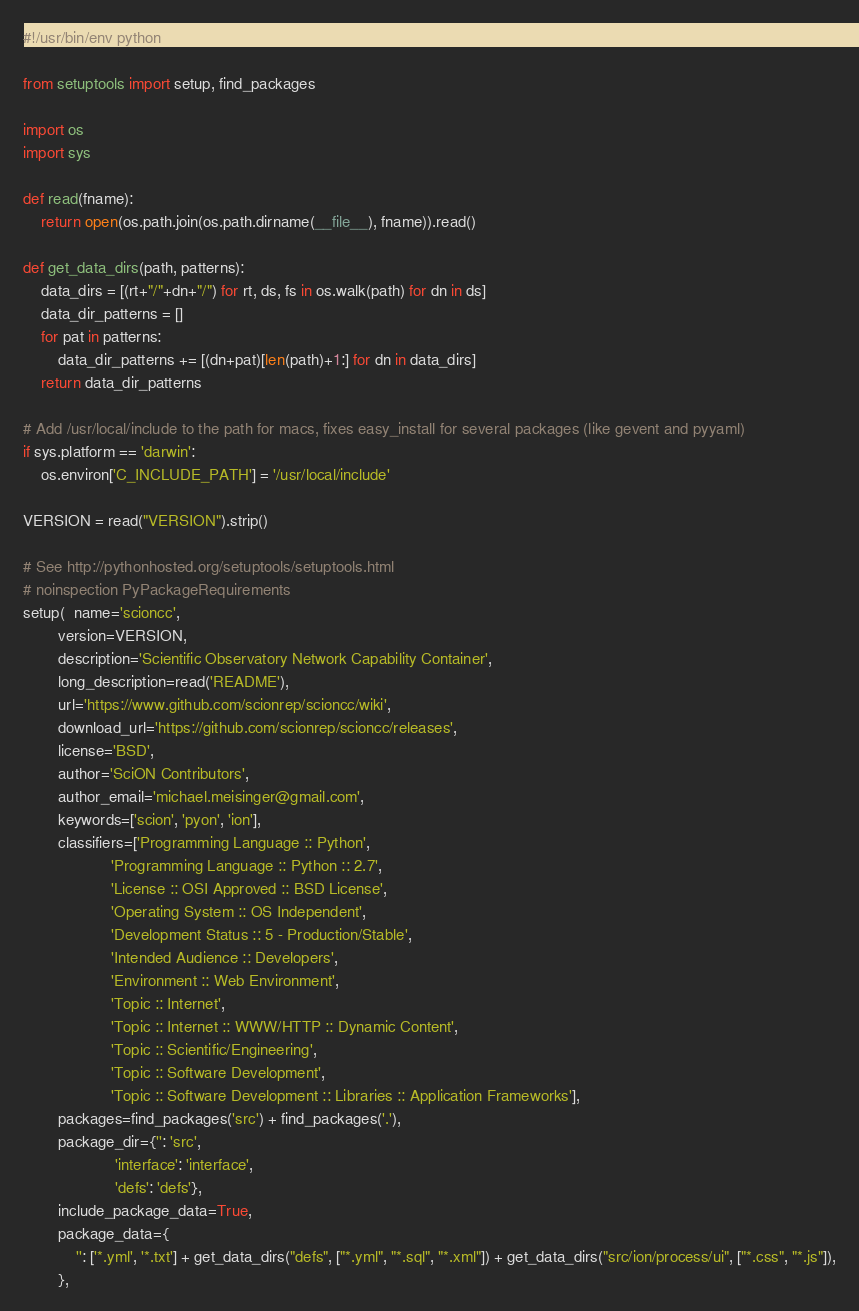<code> <loc_0><loc_0><loc_500><loc_500><_Python_>#!/usr/bin/env python

from setuptools import setup, find_packages

import os
import sys

def read(fname):
    return open(os.path.join(os.path.dirname(__file__), fname)).read()

def get_data_dirs(path, patterns):
    data_dirs = [(rt+"/"+dn+"/") for rt, ds, fs in os.walk(path) for dn in ds]
    data_dir_patterns = []
    for pat in patterns:
        data_dir_patterns += [(dn+pat)[len(path)+1:] for dn in data_dirs]
    return data_dir_patterns

# Add /usr/local/include to the path for macs, fixes easy_install for several packages (like gevent and pyyaml)
if sys.platform == 'darwin':
    os.environ['C_INCLUDE_PATH'] = '/usr/local/include'

VERSION = read("VERSION").strip()

# See http://pythonhosted.org/setuptools/setuptools.html
# noinspection PyPackageRequirements
setup(  name='scioncc',
        version=VERSION,
        description='Scientific Observatory Network Capability Container',
        long_description=read('README'),
        url='https://www.github.com/scionrep/scioncc/wiki',
        download_url='https://github.com/scionrep/scioncc/releases',
        license='BSD',
        author='SciON Contributors',
        author_email='michael.meisinger@gmail.com',
        keywords=['scion', 'pyon', 'ion'],
        classifiers=['Programming Language :: Python',
                    'Programming Language :: Python :: 2.7',
                    'License :: OSI Approved :: BSD License',
                    'Operating System :: OS Independent',
                    'Development Status :: 5 - Production/Stable',
                    'Intended Audience :: Developers',
                    'Environment :: Web Environment',
                    'Topic :: Internet',
                    'Topic :: Internet :: WWW/HTTP :: Dynamic Content',
                    'Topic :: Scientific/Engineering',
                    'Topic :: Software Development',
                    'Topic :: Software Development :: Libraries :: Application Frameworks'],
        packages=find_packages('src') + find_packages('.'),
        package_dir={'': 'src',
                     'interface': 'interface',
                     'defs': 'defs'},
        include_package_data=True,
        package_data={
            '': ['*.yml', '*.txt'] + get_data_dirs("defs", ["*.yml", "*.sql", "*.xml"]) + get_data_dirs("src/ion/process/ui", ["*.css", "*.js"]),
        },</code> 